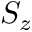<formula> <loc_0><loc_0><loc_500><loc_500>S _ { z }</formula> 